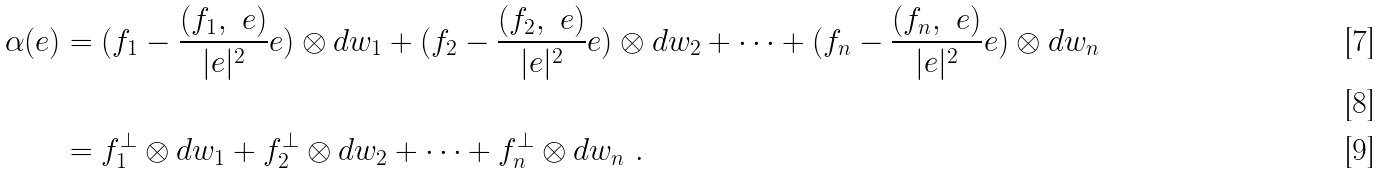Convert formula to latex. <formula><loc_0><loc_0><loc_500><loc_500>\alpha ( e ) & = ( f _ { 1 } - \frac { ( f _ { 1 } , \ e ) } { | e | ^ { 2 } } e ) \otimes d w _ { 1 } + ( f _ { 2 } - \frac { ( f _ { 2 } , \ e ) } { | e | ^ { 2 } } e ) \otimes d w _ { 2 } + \dots + ( f _ { n } - \frac { ( f _ { n } , \ e ) } { | e | ^ { 2 } } e ) \otimes d w _ { n } \\ \ \\ & = f _ { 1 } ^ { \perp } \otimes d w _ { 1 } + f _ { 2 } ^ { \perp } \otimes d w _ { 2 } + \dots + f _ { n } ^ { \perp } \otimes d w _ { n } \ .</formula> 